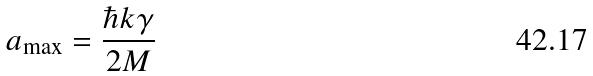Convert formula to latex. <formula><loc_0><loc_0><loc_500><loc_500>a _ { \max } = \frac { \hbar { k } \gamma } { 2 M }</formula> 